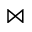<formula> <loc_0><loc_0><loc_500><loc_500>\bowtie</formula> 